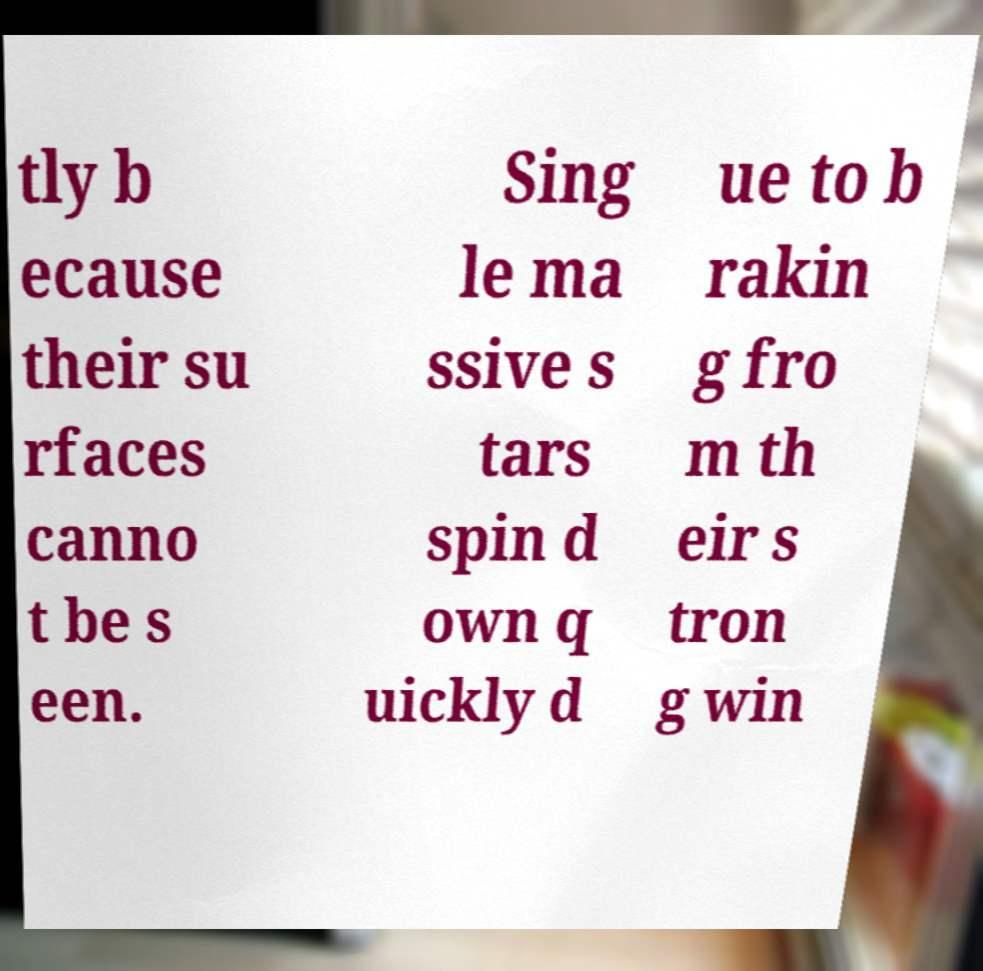For documentation purposes, I need the text within this image transcribed. Could you provide that? tly b ecause their su rfaces canno t be s een. Sing le ma ssive s tars spin d own q uickly d ue to b rakin g fro m th eir s tron g win 